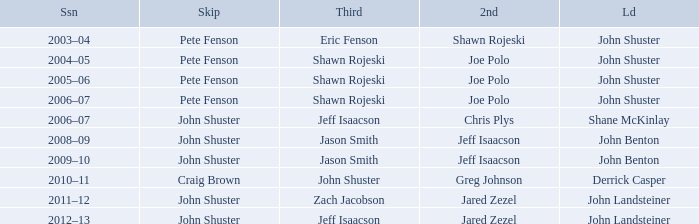Which season has Zach Jacobson in third? 2011–12. 